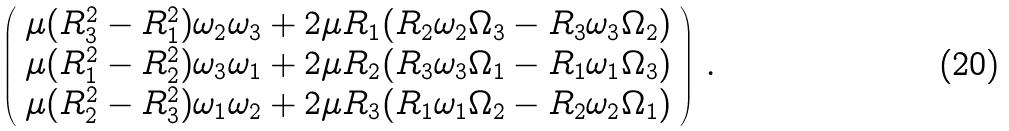<formula> <loc_0><loc_0><loc_500><loc_500>\left ( \begin{array} { c c c } \mu ( R _ { 3 } ^ { 2 } - R _ { 1 } ^ { 2 } ) \omega _ { 2 } \omega _ { 3 } + 2 \mu R _ { 1 } ( R _ { 2 } \omega _ { 2 } \Omega _ { 3 } - R _ { 3 } \omega _ { 3 } \Omega _ { 2 } ) \\ \mu ( R _ { 1 } ^ { 2 } - R _ { 2 } ^ { 2 } ) \omega _ { 3 } \omega _ { 1 } + 2 \mu R _ { 2 } ( R _ { 3 } \omega _ { 3 } \Omega _ { 1 } - R _ { 1 } \omega _ { 1 } \Omega _ { 3 } ) \\ \mu ( R _ { 2 } ^ { 2 } - R _ { 3 } ^ { 2 } ) \omega _ { 1 } \omega _ { 2 } + 2 \mu R _ { 3 } ( R _ { 1 } \omega _ { 1 } \Omega _ { 2 } - R _ { 2 } \omega _ { 2 } \Omega _ { 1 } ) \end{array} \right ) \, .</formula> 